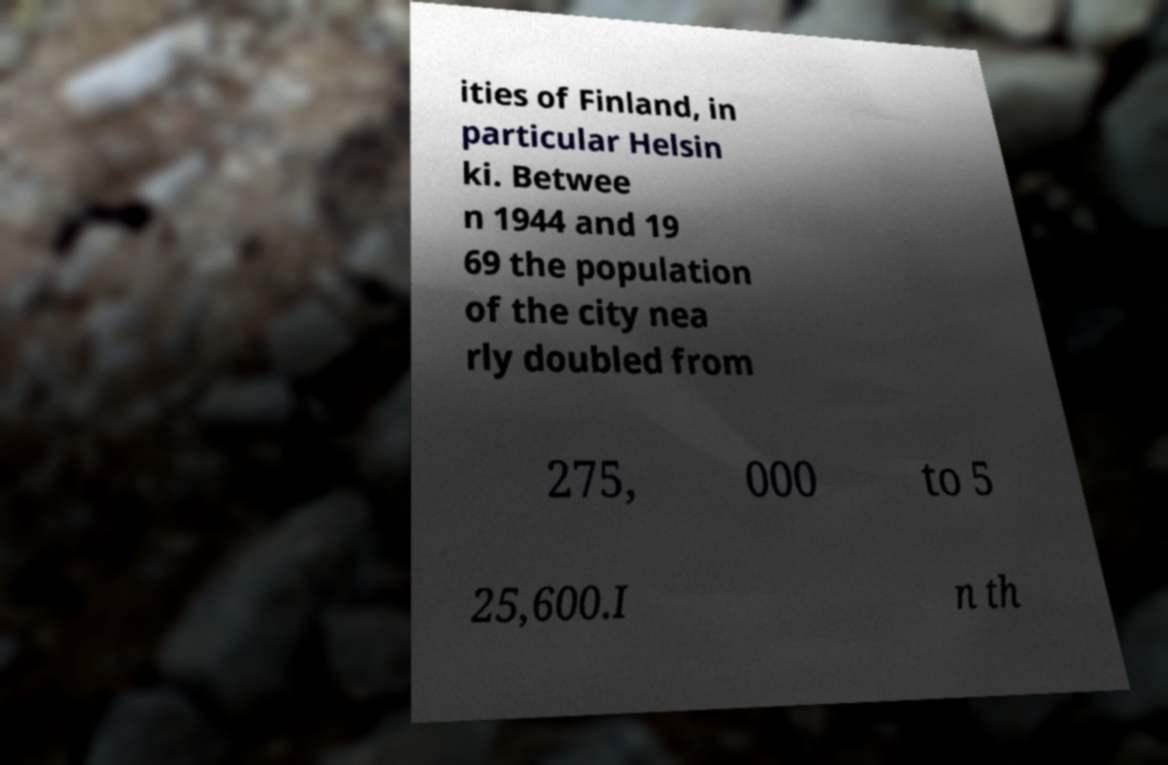Can you accurately transcribe the text from the provided image for me? ities of Finland, in particular Helsin ki. Betwee n 1944 and 19 69 the population of the city nea rly doubled from 275, 000 to 5 25,600.I n th 